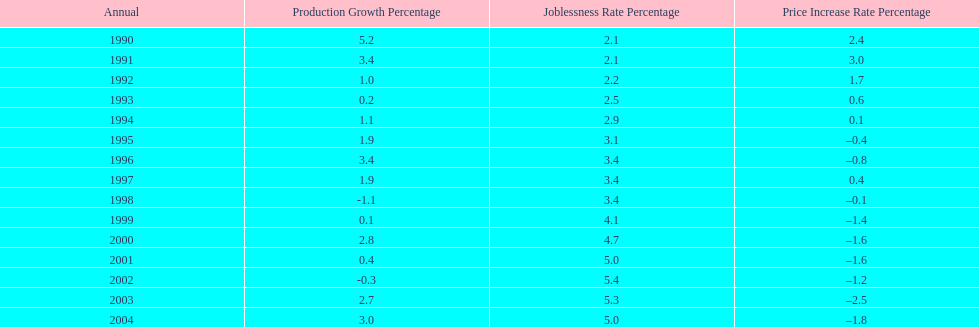Were the highest unemployment rates in japan before or after the year 2000? After. 